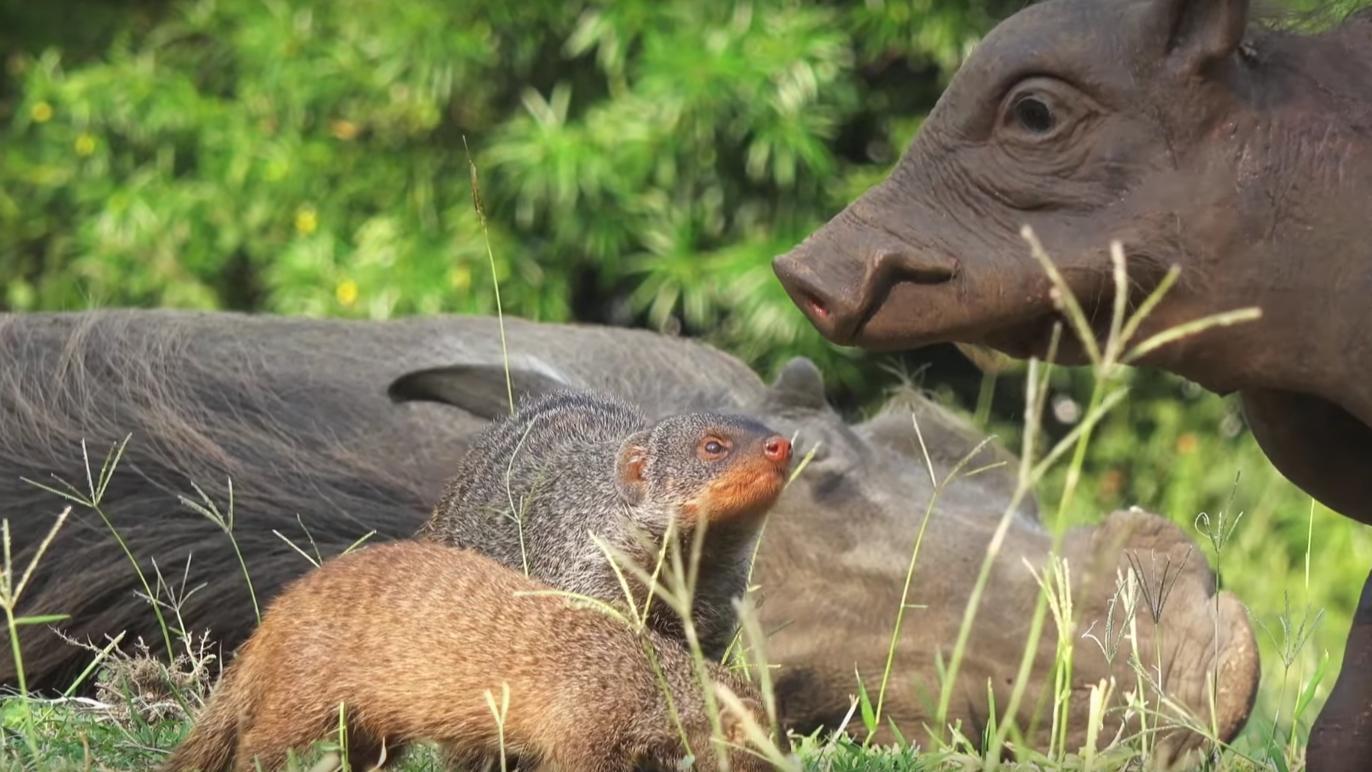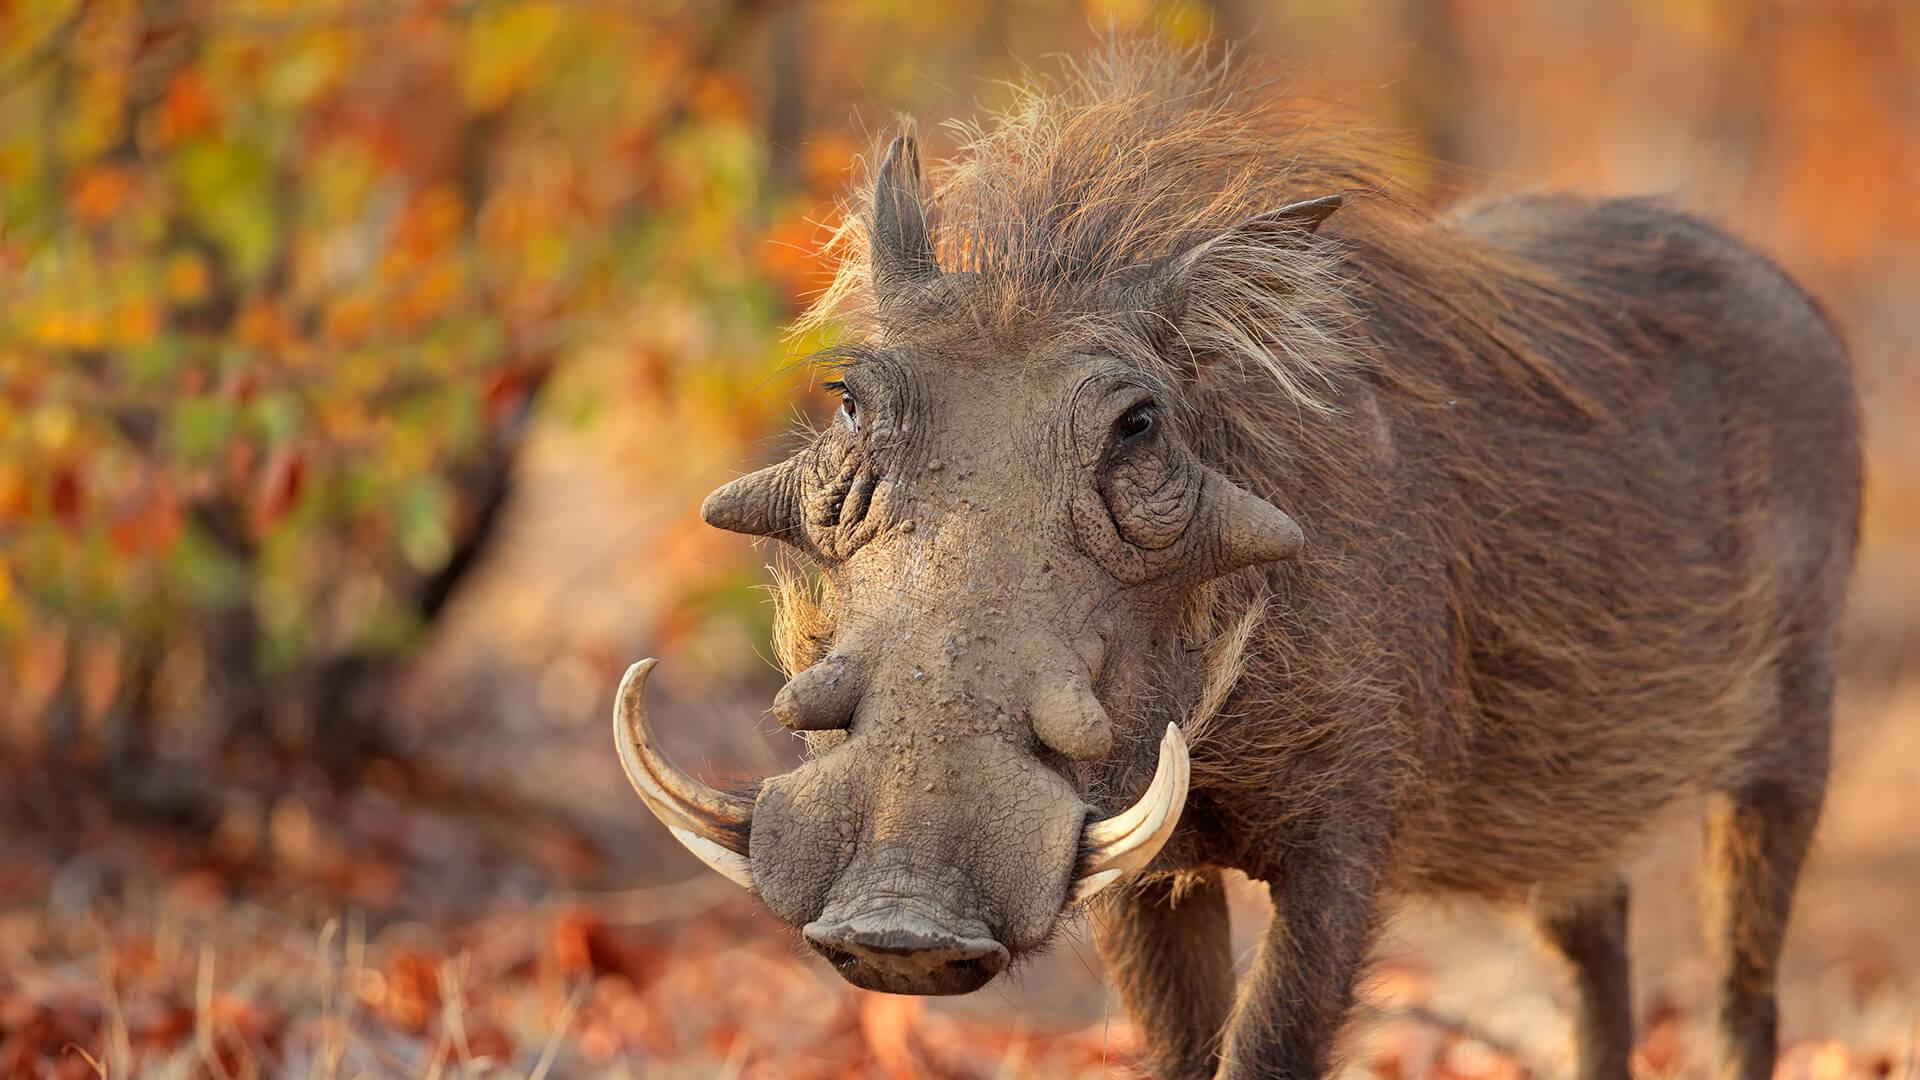The first image is the image on the left, the second image is the image on the right. For the images displayed, is the sentence "There are more than one animals in on of the images." factually correct? Answer yes or no. Yes. The first image is the image on the left, the second image is the image on the right. Considering the images on both sides, is "An image contains both juvenile and adult warthogs, and features small animals standing by a taller animal." valid? Answer yes or no. Yes. 